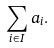Convert formula to latex. <formula><loc_0><loc_0><loc_500><loc_500>\sum _ { i \in I } a _ { i } .</formula> 